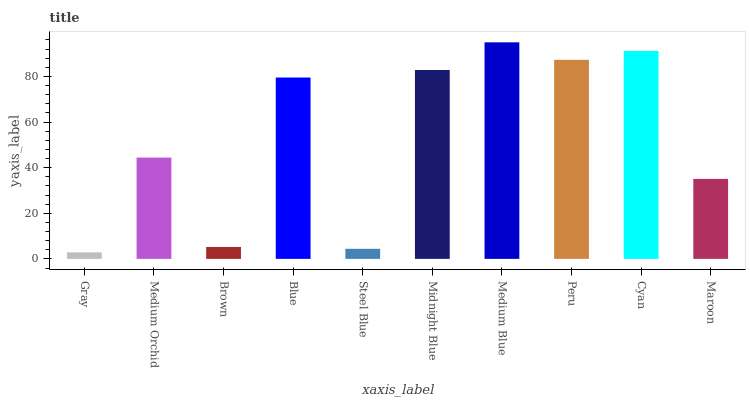Is Gray the minimum?
Answer yes or no. Yes. Is Medium Blue the maximum?
Answer yes or no. Yes. Is Medium Orchid the minimum?
Answer yes or no. No. Is Medium Orchid the maximum?
Answer yes or no. No. Is Medium Orchid greater than Gray?
Answer yes or no. Yes. Is Gray less than Medium Orchid?
Answer yes or no. Yes. Is Gray greater than Medium Orchid?
Answer yes or no. No. Is Medium Orchid less than Gray?
Answer yes or no. No. Is Blue the high median?
Answer yes or no. Yes. Is Medium Orchid the low median?
Answer yes or no. Yes. Is Steel Blue the high median?
Answer yes or no. No. Is Gray the low median?
Answer yes or no. No. 